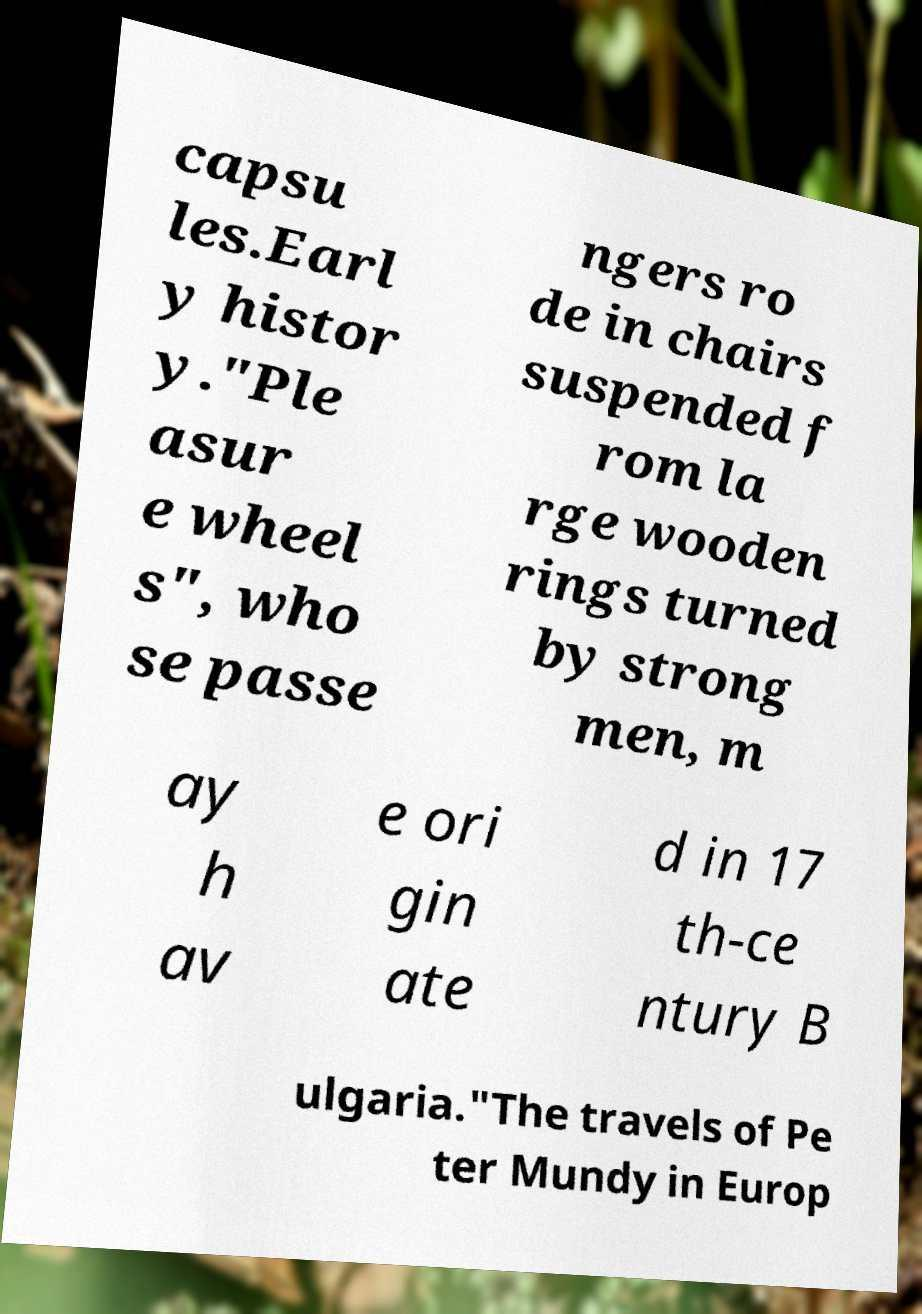Could you extract and type out the text from this image? capsu les.Earl y histor y."Ple asur e wheel s", who se passe ngers ro de in chairs suspended f rom la rge wooden rings turned by strong men, m ay h av e ori gin ate d in 17 th-ce ntury B ulgaria."The travels of Pe ter Mundy in Europ 